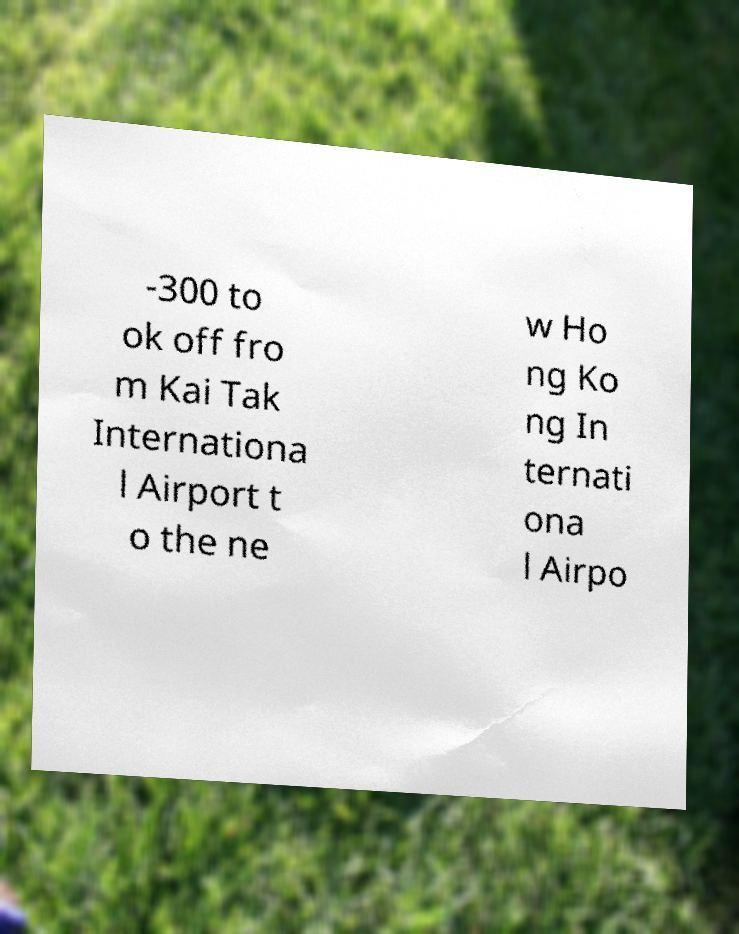Please identify and transcribe the text found in this image. -300 to ok off fro m Kai Tak Internationa l Airport t o the ne w Ho ng Ko ng In ternati ona l Airpo 